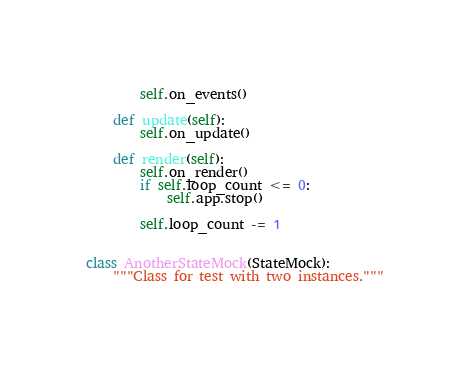Convert code to text. <code><loc_0><loc_0><loc_500><loc_500><_Python_>        self.on_events()

    def update(self):
        self.on_update()

    def render(self):
        self.on_render()
        if self.loop_count <= 0:
            self.app.stop()

        self.loop_count -= 1


class AnotherStateMock(StateMock):
    """Class for test with two instances."""
</code> 